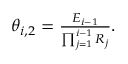<formula> <loc_0><loc_0><loc_500><loc_500>\begin{array} { r } { \theta _ { i , 2 } = \frac { E _ { i - 1 } } { \prod _ { j = 1 } ^ { i - 1 } R _ { j } } . } \end{array}</formula> 